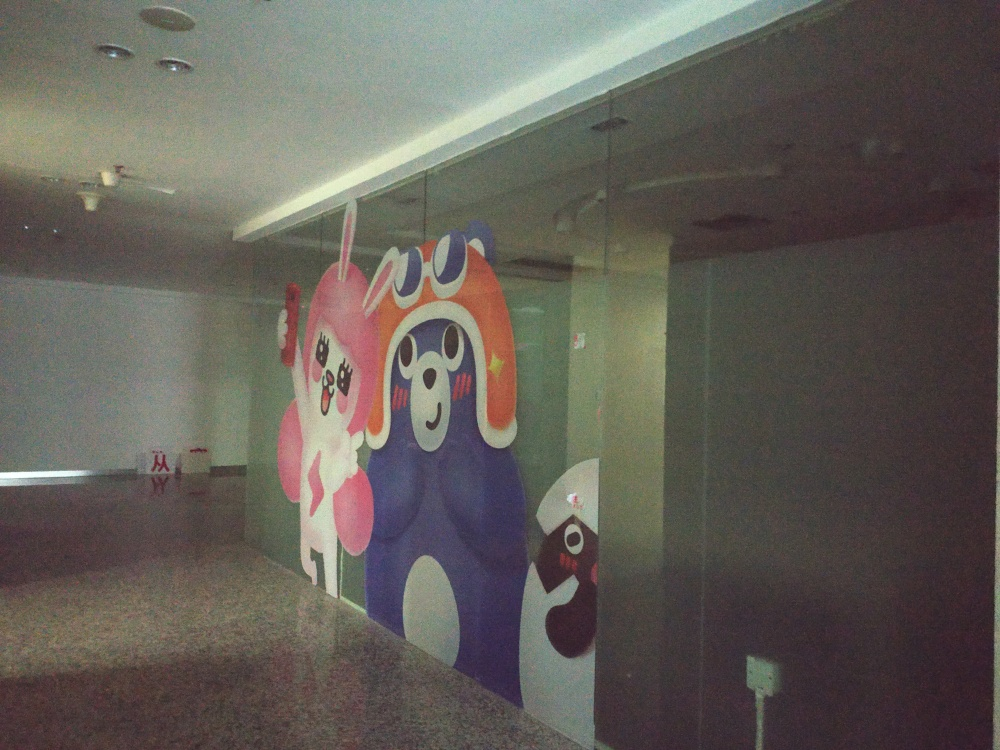Can you suggest how the artwork might be associated with the location it is displayed in? The artwork's vibrant and animated characters could indicate that the location is aimed towards a younger audience or seeks to evoke a sense of fun and creativity. It might be displayed in a place such as a children's hospital, pediatric clinic, family-friendly entertainment center, or an educational institution, aiming to create a welcoming atmosphere and potentially reduce stress or anxiety for visitors. 